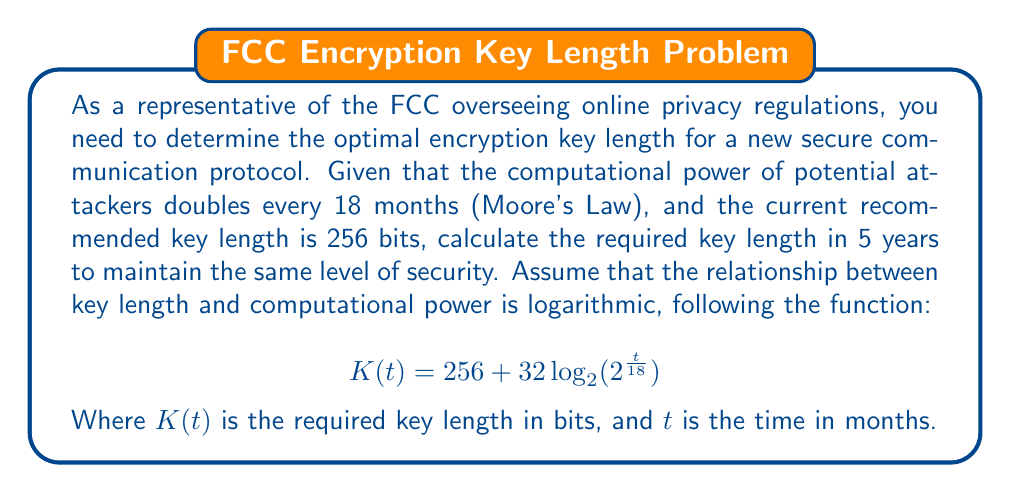Provide a solution to this math problem. To solve this problem, we'll follow these steps:

1. Identify the given information:
   - Current key length: 256 bits
   - Time frame: 5 years = 60 months
   - Function: $K(t) = 256 + 32 \log_2(2^{\frac{t}{18}})$

2. Substitute the time (t = 60 months) into the function:
   $K(60) = 256 + 32 \log_2(2^{\frac{60}{18}})$

3. Simplify the expression inside the logarithm:
   $K(60) = 256 + 32 \log_2(2^{\frac{10}{3}})$

4. Use the logarithm property $\log_a(a^x) = x$:
   $K(60) = 256 + 32 \cdot \frac{10}{3}$

5. Calculate the result:
   $K(60) = 256 + \frac{320}{3} \approx 362.67$

6. Round up to the nearest whole number, as key lengths are typically expressed in whole bits:
   $K(60) \approx 363$ bits

Therefore, the optimal encryption key length in 5 years would be 363 bits.
Answer: 363 bits 